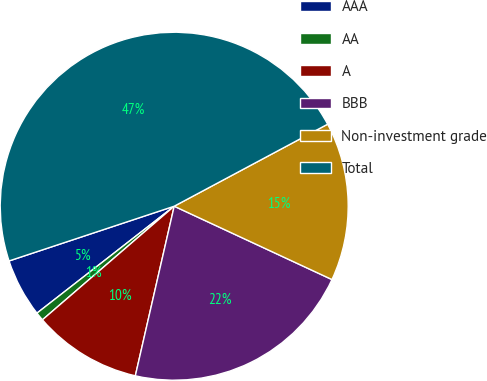<chart> <loc_0><loc_0><loc_500><loc_500><pie_chart><fcel>AAA<fcel>AA<fcel>A<fcel>BBB<fcel>Non-investment grade<fcel>Total<nl><fcel>5.44%<fcel>0.79%<fcel>10.09%<fcel>21.66%<fcel>14.74%<fcel>47.28%<nl></chart> 